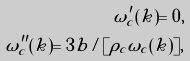<formula> <loc_0><loc_0><loc_500><loc_500>\omega _ { c } ^ { \prime } ( k ) = 0 , \\ \omega _ { c } ^ { \prime \prime } ( k ) = { 3 b / [ \rho _ { c } \omega _ { c } ( k ) ] } ,</formula> 